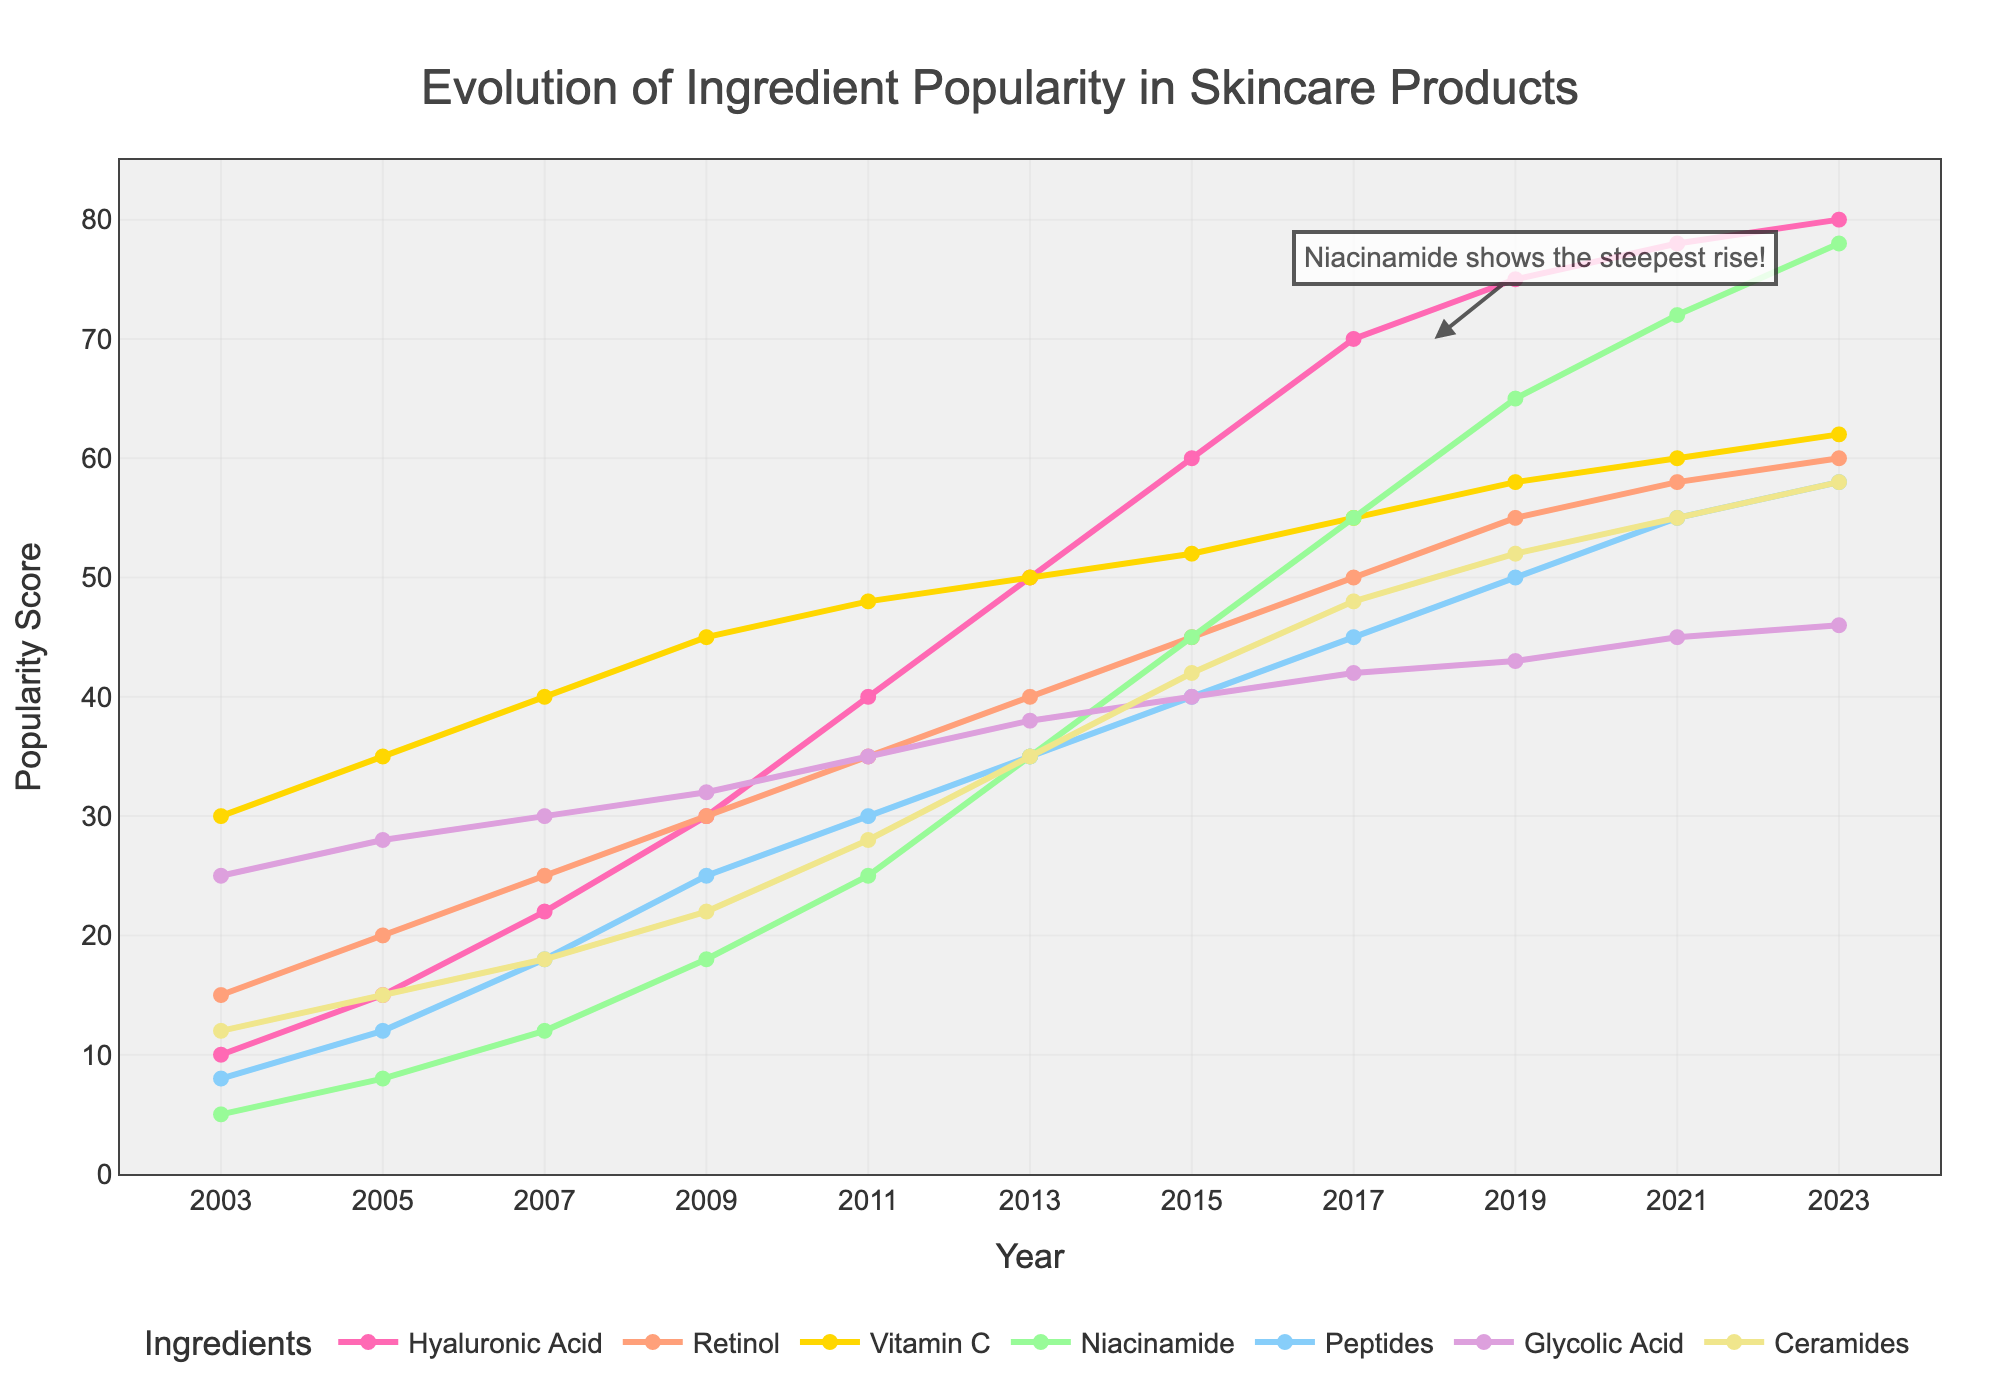What ingredient had the highest popularity score in 2023? Look at the figure and identify the ingredient with the highest point in 2023. Hyaluronic Acid tops at 80.
Answer: Hyaluronic Acid Which ingredient showed the most significant rise in popularity from 2017 to 2023? Check and compare the height increase of the lines for all ingredients between 2017 and 2023. Niacinamide rose from 55 to 78, the steepest increase.
Answer: Niacinamide What is the combined popularity score of Hyaluronic Acid and Vitamin C in 2021? Find the scores for Hyaluronic Acid (78) and Vitamin C (60) in 2021, then add them together. 78 + 60 = 138
Answer: 138 Which ingredient had relatively stable popularity trends from 2003 to 2023? Observe the slopes of each line. Ceramides show a stable, steady upward trend without sharp spikes or dips.
Answer: Ceramides How many ingredients had a popularity score greater than 50 in 2023? Check the 2023 scores for each ingredient and count those exceeding 50. Hyaluronic Acid, Retinol, Vitamin C, Niacinamide, and Peptides exceed 50.
Answer: 5 Compare the popularity score of Niacinamide and Peptides in 2011. Which one was more popular? Look at the points for Niacinamide (25) and Peptides (30) in 2011. Peptides had a higher score.
Answer: Peptides Between Glycolic Acid and Retinol, which ingredient had a higher increase from 2009 to 2015? Calculate the score differences for Retinol (45-30=15) and Glycolic Acid (40-32=8). Retinol increased more.
Answer: Retinol Which ingredient has the fastest growth rate in terms of popularity over the entire period from 2003 to 2023? Assess the slopes of all ingredient lines over the entire period. Niacinamide demonstrates the steepest upward trend overall.
Answer: Niacinamide What was the average popularity score of Vitamin C from 2003 to 2023? Sum the scores for Vitamin C across all years (30+35+40+45+48+50+52+55+58+60+62=535). Average = 535 / 11 ≈ 48.64
Answer: ~48.64 What year did Niacinamide surpass Peptides in popularity? Locate the year when Niacinamide's trend line crosses and goes above Peptides. This happened in 2017 when Niacinamide (55) surpassed Peptides (45).
Answer: 2017 